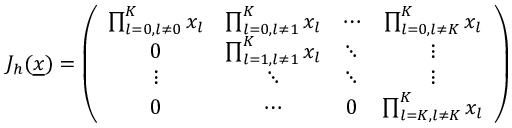<formula> <loc_0><loc_0><loc_500><loc_500>\begin{array} { r } { J _ { h } ( \underline { x } ) = \left ( \begin{array} { c c c c } { \prod _ { l = 0 , l \not = 0 } ^ { K } x _ { l } } & { \prod _ { l = 0 , l \not = 1 } ^ { K } x _ { l } } & { \cdots } & { \prod _ { l = 0 , l \not = K } ^ { K } x _ { l } } \\ { 0 } & { \prod _ { l = 1 , l \not = 1 } ^ { K } x _ { l } } & { \ddots } & { \vdots } \\ { \vdots } & { \ddots } & { \ddots } & { \vdots } \\ { 0 } & { \cdots } & { 0 } & { \prod _ { l = K , l \not = K } ^ { K } x _ { l } } \end{array} \right ) } \end{array}</formula> 